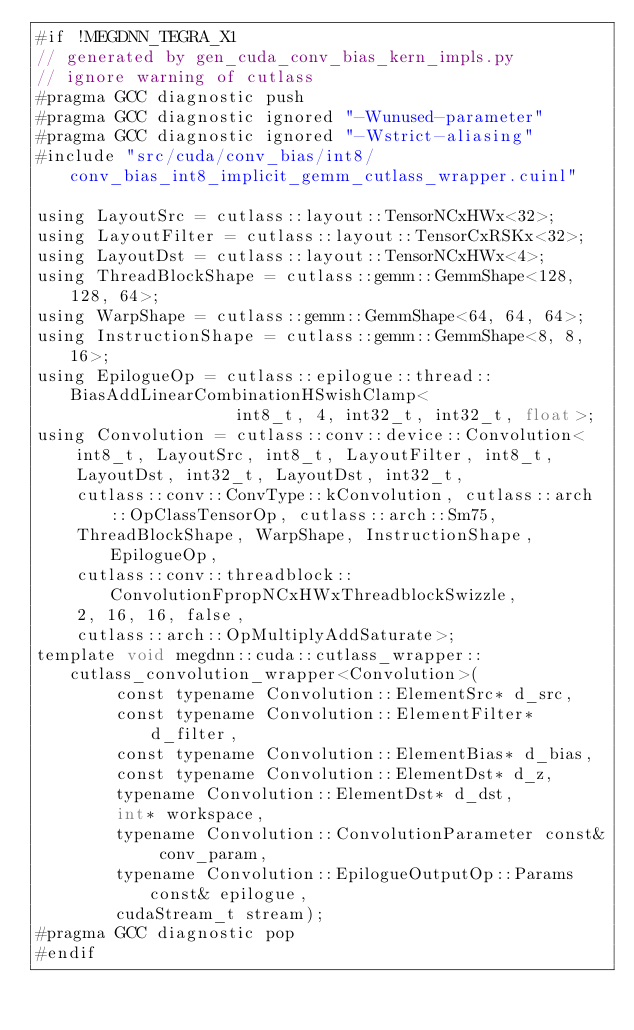Convert code to text. <code><loc_0><loc_0><loc_500><loc_500><_Cuda_>#if !MEGDNN_TEGRA_X1
// generated by gen_cuda_conv_bias_kern_impls.py
// ignore warning of cutlass
#pragma GCC diagnostic push
#pragma GCC diagnostic ignored "-Wunused-parameter"
#pragma GCC diagnostic ignored "-Wstrict-aliasing"
#include "src/cuda/conv_bias/int8/conv_bias_int8_implicit_gemm_cutlass_wrapper.cuinl"

using LayoutSrc = cutlass::layout::TensorNCxHWx<32>;
using LayoutFilter = cutlass::layout::TensorCxRSKx<32>;
using LayoutDst = cutlass::layout::TensorNCxHWx<4>;
using ThreadBlockShape = cutlass::gemm::GemmShape<128, 128, 64>;
using WarpShape = cutlass::gemm::GemmShape<64, 64, 64>;
using InstructionShape = cutlass::gemm::GemmShape<8, 8, 16>;
using EpilogueOp = cutlass::epilogue::thread::BiasAddLinearCombinationHSwishClamp<
                    int8_t, 4, int32_t, int32_t, float>;
using Convolution = cutlass::conv::device::Convolution<
    int8_t, LayoutSrc, int8_t, LayoutFilter, int8_t, 
    LayoutDst, int32_t, LayoutDst, int32_t, 
    cutlass::conv::ConvType::kConvolution, cutlass::arch::OpClassTensorOp, cutlass::arch::Sm75, 
    ThreadBlockShape, WarpShape, InstructionShape, EpilogueOp, 
    cutlass::conv::threadblock::ConvolutionFpropNCxHWxThreadblockSwizzle, 
    2, 16, 16, false, 
    cutlass::arch::OpMultiplyAddSaturate>;
template void megdnn::cuda::cutlass_wrapper::cutlass_convolution_wrapper<Convolution>(
        const typename Convolution::ElementSrc* d_src, 
        const typename Convolution::ElementFilter* d_filter, 
        const typename Convolution::ElementBias* d_bias, 
        const typename Convolution::ElementDst* d_z, 
        typename Convolution::ElementDst* d_dst, 
        int* workspace, 
        typename Convolution::ConvolutionParameter const& conv_param, 
        typename Convolution::EpilogueOutputOp::Params const& epilogue, 
        cudaStream_t stream);
#pragma GCC diagnostic pop
#endif
</code> 